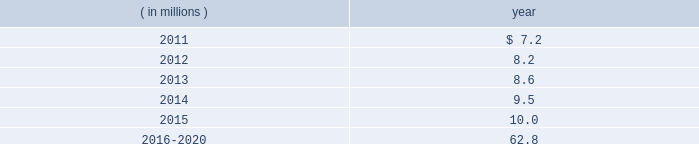The company expects to amortize $ 1.7 million of actuarial loss from accumulated other comprehensive income ( loss ) into net periodic benefit costs in 2011 .
At december 31 , 2010 , anticipated benefit payments from the plan in future years are as follows: .
Savings plans .
Cme maintains a defined contribution savings plan pursuant to section 401 ( k ) of the internal revenue code , whereby all u.s .
Employees are participants and have the option to contribute to this plan .
Cme matches employee contributions up to 3% ( 3 % ) of the employee 2019s base salary and may make additional discretionary contributions of up to 2% ( 2 % ) of base salary .
In addition , certain cme london-based employees are eligible to participate in a defined contribution plan .
For cme london-based employees , the plan provides for company contributions of 10% ( 10 % ) of earnings and does not have any vesting requirements .
Salary and cash bonuses paid are included in the definition of earnings .
Aggregate expense for all of the defined contribution savings plans amounted to $ 6.3 million , $ 5.2 million and $ 5.8 million in 2010 , 2009 and 2008 , respectively .
Cme non-qualified plans .
Cme maintains non-qualified plans , under which participants may make assumed investment choices with respect to amounts contributed on their behalf .
Although not required to do so , cme invests such contributions in assets that mirror the assumed investment choices .
The balances in these plans are subject to the claims of general creditors of the exchange and totaled $ 28.8 million and $ 23.4 million at december 31 , 2010 and 2009 , respectively .
Although the value of the plans is recorded as an asset in the consolidated balance sheets , there is an equal and offsetting liability .
The investment results of these plans have no impact on net income as the investment results are recorded in equal amounts to both investment income and compensation and benefits expense .
Supplemental savings plan 2014cme maintains a supplemental plan to provide benefits for employees who have been impacted by statutory limits under the provisions of the qualified pension and savings plan .
All cme employees hired prior to january 1 , 2007 are immediately vested in their supplemental plan benefits .
All cme employees hired on or after january 1 , 2007 are subject to the vesting requirements of the underlying qualified plans .
Total expense for the supplemental plan was $ 0.9 million , $ 0.7 million and $ 1.3 million for 2010 , 2009 and 2008 , respectively .
Deferred compensation plan 2014a deferred compensation plan is maintained by cme , under which eligible officers and members of the board of directors may contribute a percentage of their compensation and defer income taxes thereon until the time of distribution .
Nymexmembers 2019 retirement plan and benefits .
Nymex maintained a retirement and benefit plan under the commodities exchange , inc .
( comex ) members 2019 recognition and retention plan ( mrrp ) .
This plan provides benefits to certain members of the comex division based on long-term membership , and participation is limited to individuals who were comex division members prior to nymex 2019s acquisition of comex in 1994 .
No new participants were permitted into the plan after the date of this acquisition .
Under the terms of the mrrp , the company is required to fund the plan with a minimum annual contribution of $ 0.4 million until it is fully funded .
All benefits to be paid under the mrrp are based on reasonable actuarial assumptions which are based upon the amounts that are available and are expected to be available to pay benefits .
Total contributions to the plan were $ 0.8 million for each of 2010 , 2009 and for the period august 23 through december 31 , 2008 .
At december 31 , 2010 and 2009 , the total obligation for the mrrp totaled $ 20.7 million and $ 20.5 million .
What was the increase of the expense for all of the defined contribution savings plans in 2011 compared with 2010 , in millions? 
Rationale: its the variation between the total amount of expenses with saving plans in 2010 ( $ 6.3 millions ) and 2011 ( $ 7.2 millions ) .
Computations: (7.2 - 6.3)
Answer: 0.9. 